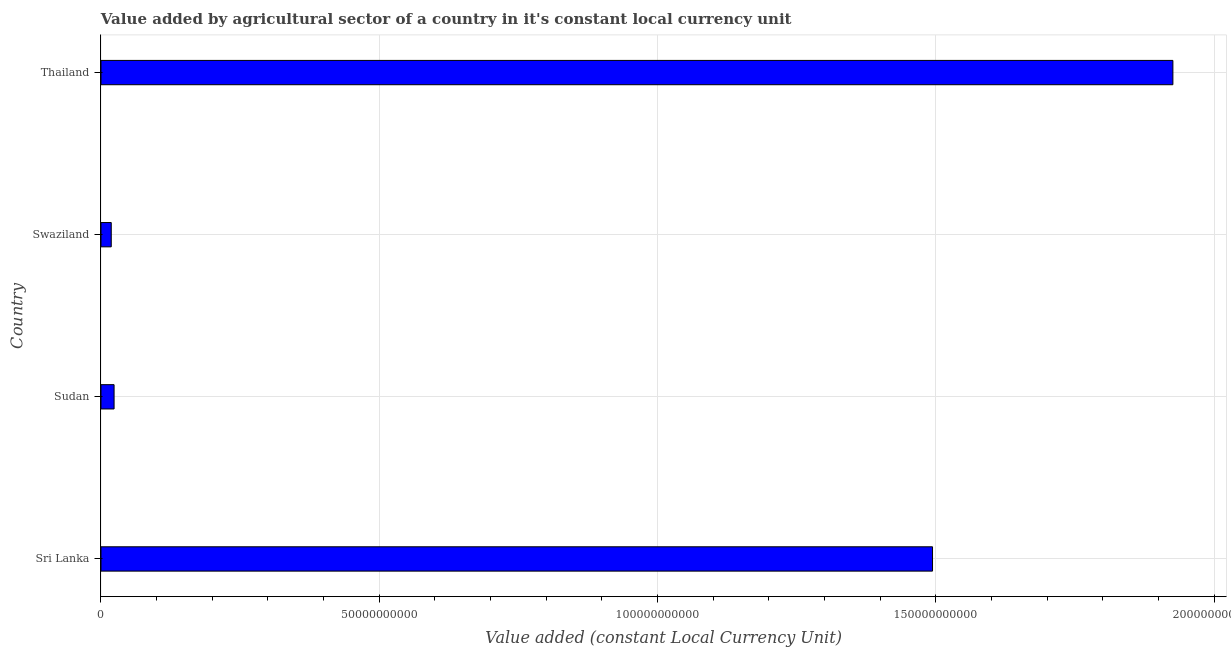Does the graph contain grids?
Your answer should be compact. Yes. What is the title of the graph?
Ensure brevity in your answer.  Value added by agricultural sector of a country in it's constant local currency unit. What is the label or title of the X-axis?
Your response must be concise. Value added (constant Local Currency Unit). What is the value added by agriculture sector in Thailand?
Your response must be concise. 1.93e+11. Across all countries, what is the maximum value added by agriculture sector?
Provide a succinct answer. 1.93e+11. Across all countries, what is the minimum value added by agriculture sector?
Your response must be concise. 1.84e+09. In which country was the value added by agriculture sector maximum?
Your response must be concise. Thailand. In which country was the value added by agriculture sector minimum?
Make the answer very short. Swaziland. What is the sum of the value added by agriculture sector?
Provide a succinct answer. 3.46e+11. What is the difference between the value added by agriculture sector in Sri Lanka and Sudan?
Offer a very short reply. 1.47e+11. What is the average value added by agriculture sector per country?
Ensure brevity in your answer.  8.65e+1. What is the median value added by agriculture sector?
Provide a succinct answer. 7.59e+1. What is the ratio of the value added by agriculture sector in Swaziland to that in Thailand?
Make the answer very short. 0.01. Is the value added by agriculture sector in Sudan less than that in Swaziland?
Your response must be concise. No. Is the difference between the value added by agriculture sector in Sri Lanka and Thailand greater than the difference between any two countries?
Offer a terse response. No. What is the difference between the highest and the second highest value added by agriculture sector?
Your answer should be compact. 4.32e+1. Is the sum of the value added by agriculture sector in Sudan and Thailand greater than the maximum value added by agriculture sector across all countries?
Offer a terse response. Yes. What is the difference between the highest and the lowest value added by agriculture sector?
Provide a short and direct response. 1.91e+11. What is the difference between two consecutive major ticks on the X-axis?
Offer a very short reply. 5.00e+1. Are the values on the major ticks of X-axis written in scientific E-notation?
Provide a succinct answer. No. What is the Value added (constant Local Currency Unit) in Sri Lanka?
Give a very brief answer. 1.49e+11. What is the Value added (constant Local Currency Unit) in Sudan?
Make the answer very short. 2.35e+09. What is the Value added (constant Local Currency Unit) of Swaziland?
Provide a short and direct response. 1.84e+09. What is the Value added (constant Local Currency Unit) in Thailand?
Offer a terse response. 1.93e+11. What is the difference between the Value added (constant Local Currency Unit) in Sri Lanka and Sudan?
Provide a short and direct response. 1.47e+11. What is the difference between the Value added (constant Local Currency Unit) in Sri Lanka and Swaziland?
Give a very brief answer. 1.48e+11. What is the difference between the Value added (constant Local Currency Unit) in Sri Lanka and Thailand?
Make the answer very short. -4.32e+1. What is the difference between the Value added (constant Local Currency Unit) in Sudan and Swaziland?
Give a very brief answer. 5.08e+08. What is the difference between the Value added (constant Local Currency Unit) in Sudan and Thailand?
Your response must be concise. -1.90e+11. What is the difference between the Value added (constant Local Currency Unit) in Swaziland and Thailand?
Provide a short and direct response. -1.91e+11. What is the ratio of the Value added (constant Local Currency Unit) in Sri Lanka to that in Sudan?
Offer a very short reply. 63.52. What is the ratio of the Value added (constant Local Currency Unit) in Sri Lanka to that in Swaziland?
Keep it short and to the point. 81.04. What is the ratio of the Value added (constant Local Currency Unit) in Sri Lanka to that in Thailand?
Offer a terse response. 0.78. What is the ratio of the Value added (constant Local Currency Unit) in Sudan to that in Swaziland?
Ensure brevity in your answer.  1.28. What is the ratio of the Value added (constant Local Currency Unit) in Sudan to that in Thailand?
Keep it short and to the point. 0.01. What is the ratio of the Value added (constant Local Currency Unit) in Swaziland to that in Thailand?
Ensure brevity in your answer.  0.01. 